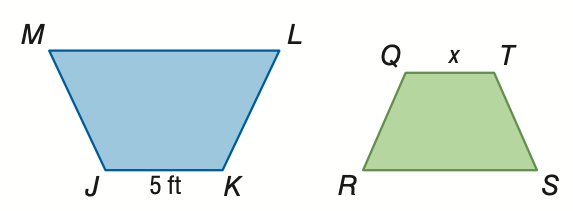Answer the mathemtical geometry problem and directly provide the correct option letter.
Question: The area of trapezoid J K L M is 138 square feet. The area of trapezoid Q R S T is 5.52 square feet. If trapezoid J K L M \sim trapezoid Q R S T, find the scale factor from trapezoid J K L M to trapezoid Q R S T.
Choices: A: \frac { 1 } { 25 } B: \frac { 1 } { 5 } C: 5 D: 25 C 